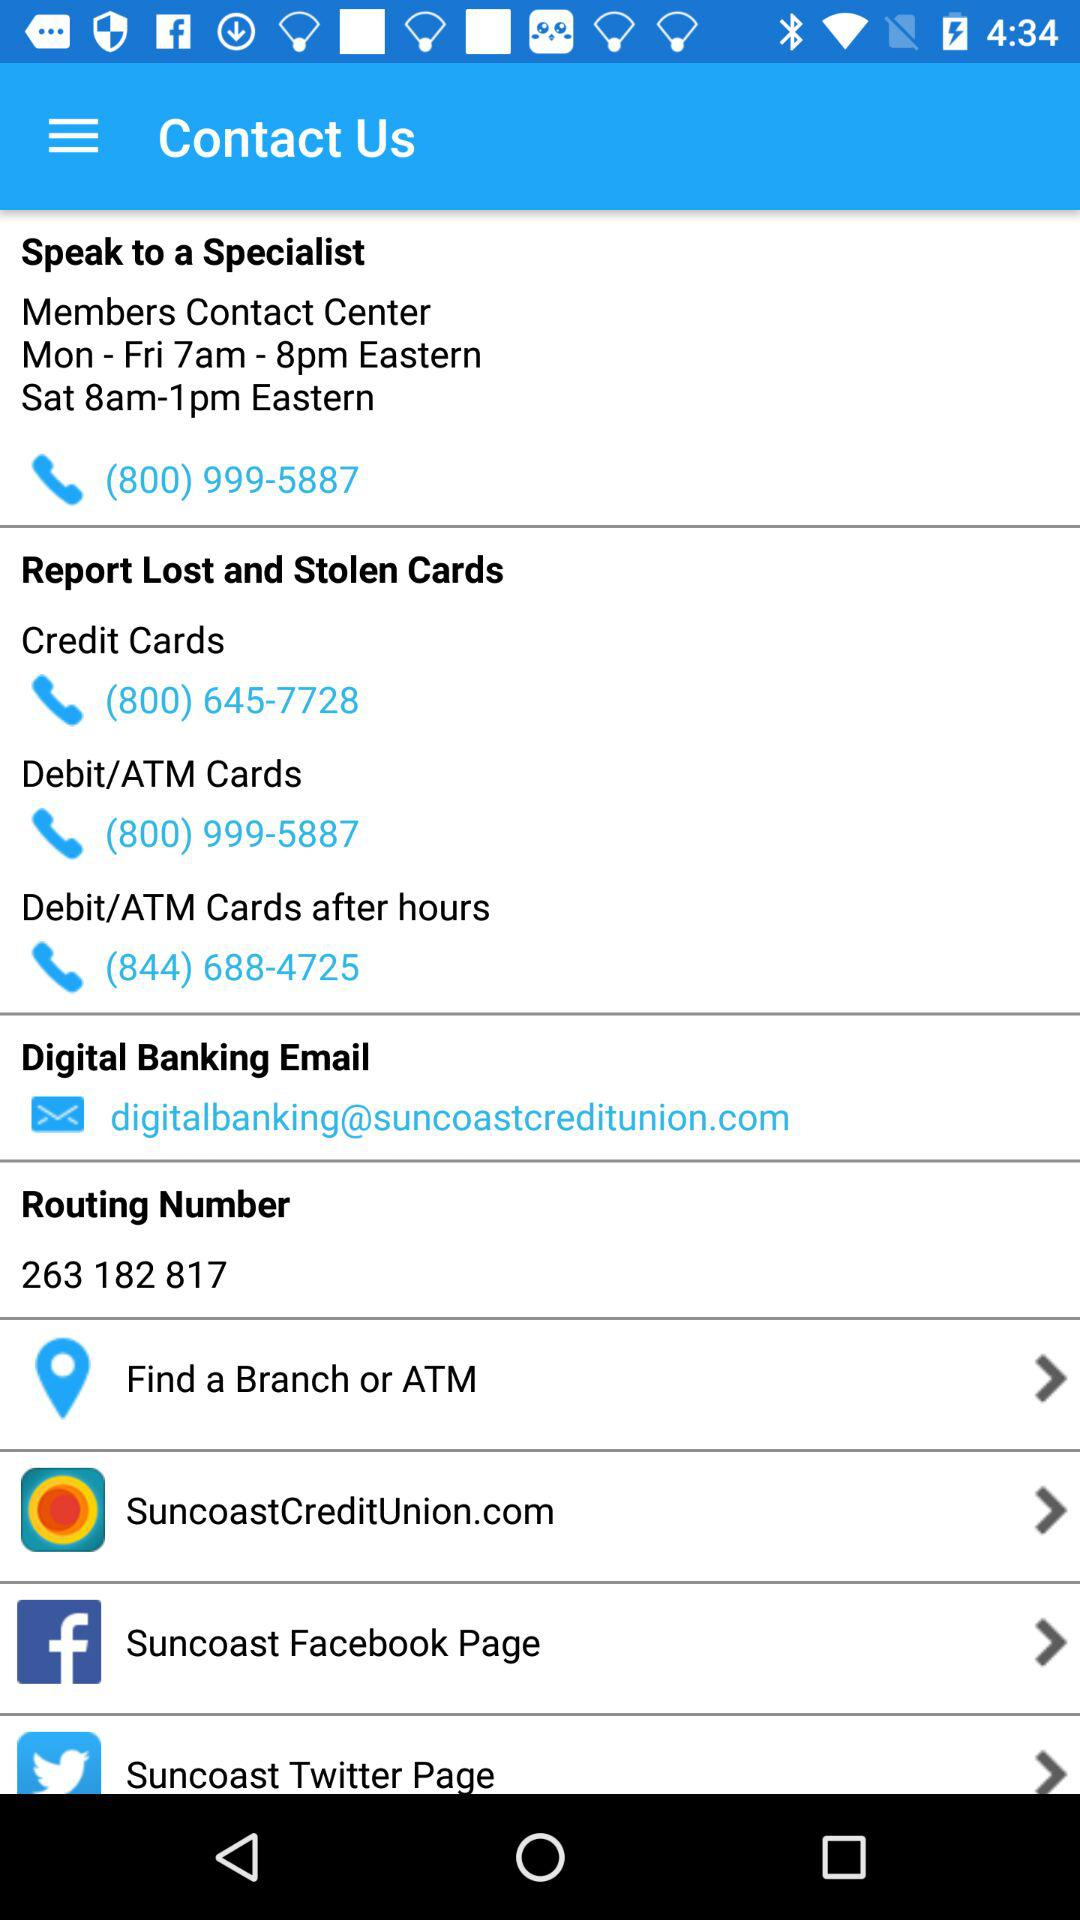What is the routing number? The routing number is 263 182 817. 